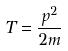Convert formula to latex. <formula><loc_0><loc_0><loc_500><loc_500>T = \frac { p ^ { 2 } } { 2 m }</formula> 